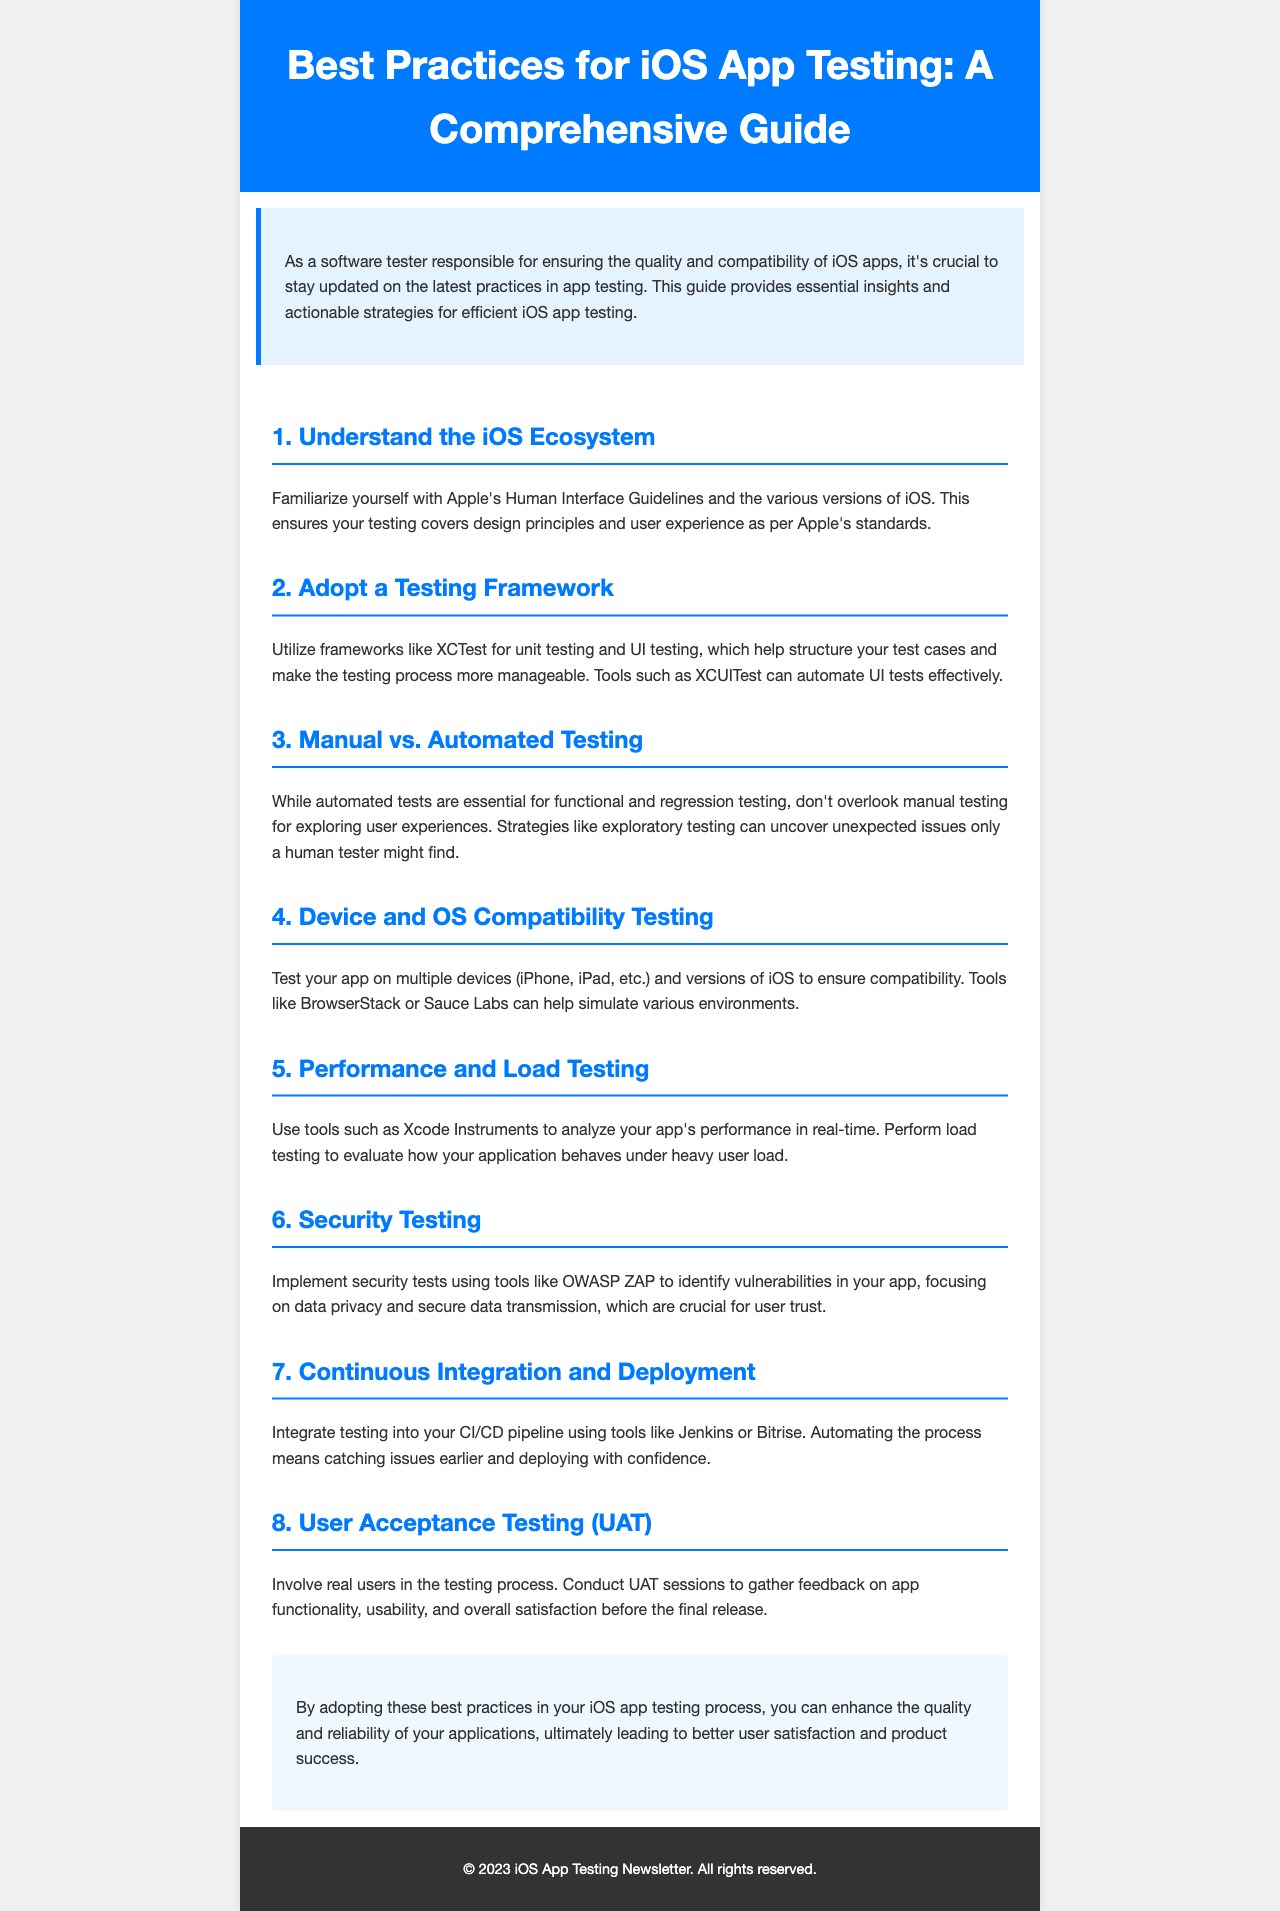What is the title of the document? The title is stated at the top of the newsletter within the header section.
Answer: Best Practices for iOS App Testing: A Comprehensive Guide How many sections are in the document? The document contains several distinct sections, each outlined with a heading.
Answer: 8 What testing framework is mentioned in section two? The second section discusses frameworks that can help structure test cases.
Answer: XCTest Which tool is recommended for security testing? The section on security testing specifies a tool that can help identify vulnerabilities.
Answer: OWASP ZAP What is the focus of User Acceptance Testing? The section outlines the main purpose of involving users in the testing process.
Answer: User feedback What should you monitor during performance testing? The document emphasizes what type of app performance should be evaluated during testing.
Answer: Real-time performance What testing strategy is suggested for uncovering unexpected issues? The reasoning in the document encourages a certain approach for testing user experiences.
Answer: Exploratory testing What is the final takeaway from the newsletter? The conclusion provides a summary of the main benefit from adopting the outlined practices.
Answer: Enhance quality and reliability 